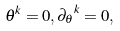<formula> <loc_0><loc_0><loc_500><loc_500>\theta ^ { k } = 0 , { \partial _ { \theta } } ^ { k } = 0 ,</formula> 